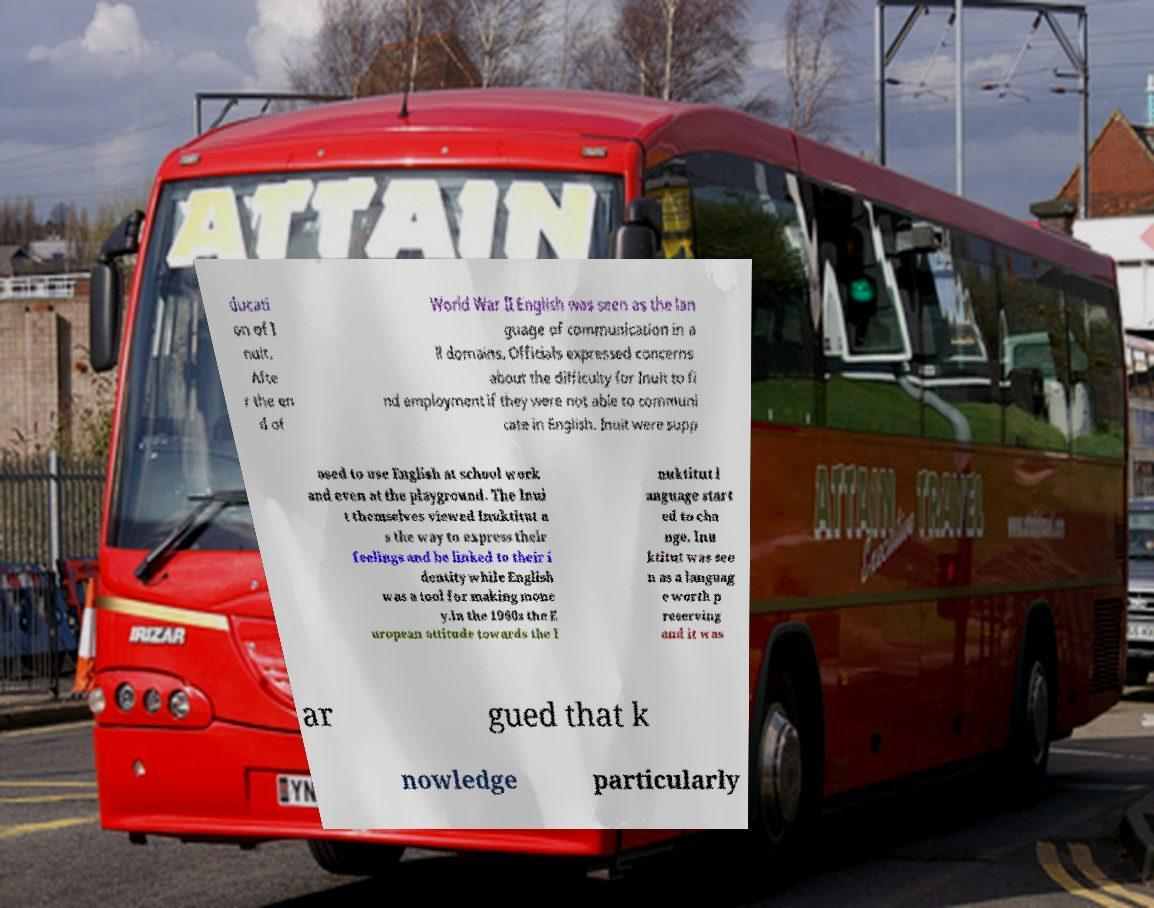Could you extract and type out the text from this image? ducati on of I nuit. Afte r the en d of World War II English was seen as the lan guage of communication in a ll domains. Officials expressed concerns about the difficulty for Inuit to fi nd employment if they were not able to communi cate in English. Inuit were supp osed to use English at school work and even at the playground. The Inui t themselves viewed Inuktitut a s the way to express their feelings and be linked to their i dentity while English was a tool for making mone y.In the 1960s the E uropean attitude towards the I nuktitut l anguage start ed to cha nge. Inu ktitut was see n as a languag e worth p reserving and it was ar gued that k nowledge particularly 